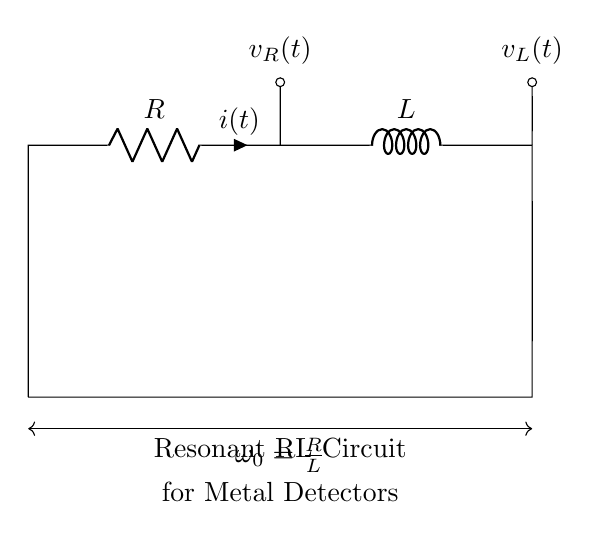What are the components in this circuit? The circuit contains a resistor and an inductor, as indicated by the symbols on the diagram. Specifically, the identifier labels "R" for the resistor and "L" for the inductor confirm their presence.
Answer: Resistor, Inductor What is the current in the circuit represented as? The current is represented by the symbol "i(t)", which shows that it is a function of time. This notation is typical for indicating current flow in circuits over time.
Answer: i(t) What does the arrow on the resistor denote? The arrow denotes the direction of current flow through the resistor. It visually indicates how the current "i(t)" flows from the left to the right through the resistor component.
Answer: i(t) What is the resonance frequency formula given in the diagram? The diagram displays the resonance frequency formula as "ω₀ = R/L", which is derived from the characteristics of the resonant RL circuit where the resonance occurs at a specific frequency determined by the resistance and inductance.
Answer: ω₀ = R/L How does the resistance affect the resonance in this circuit? Resistance affects the quality factor of the circuit; increasing resistance lowers the sharpness of resonance. With too high a resistance, the resonant peak becomes broader and less distinct, affecting sensitivity in detecting metallic objects.
Answer: Lowers sharpness What is the role of the inductor in this resonance circuit? The inductor stores energy in a magnetic field when current passes through it. In resonance, it creates a balance with the resistor to allow oscillations that can detect metal by responding to changing magnetic fields.
Answer: Stores energy What type of circuit is depicted in the diagram? The circuit is a resonant RL circuit specifically tailored for applications in metal detection, commonly used in security systems to detect the presence of metal objects.
Answer: Resonant RL circuit 